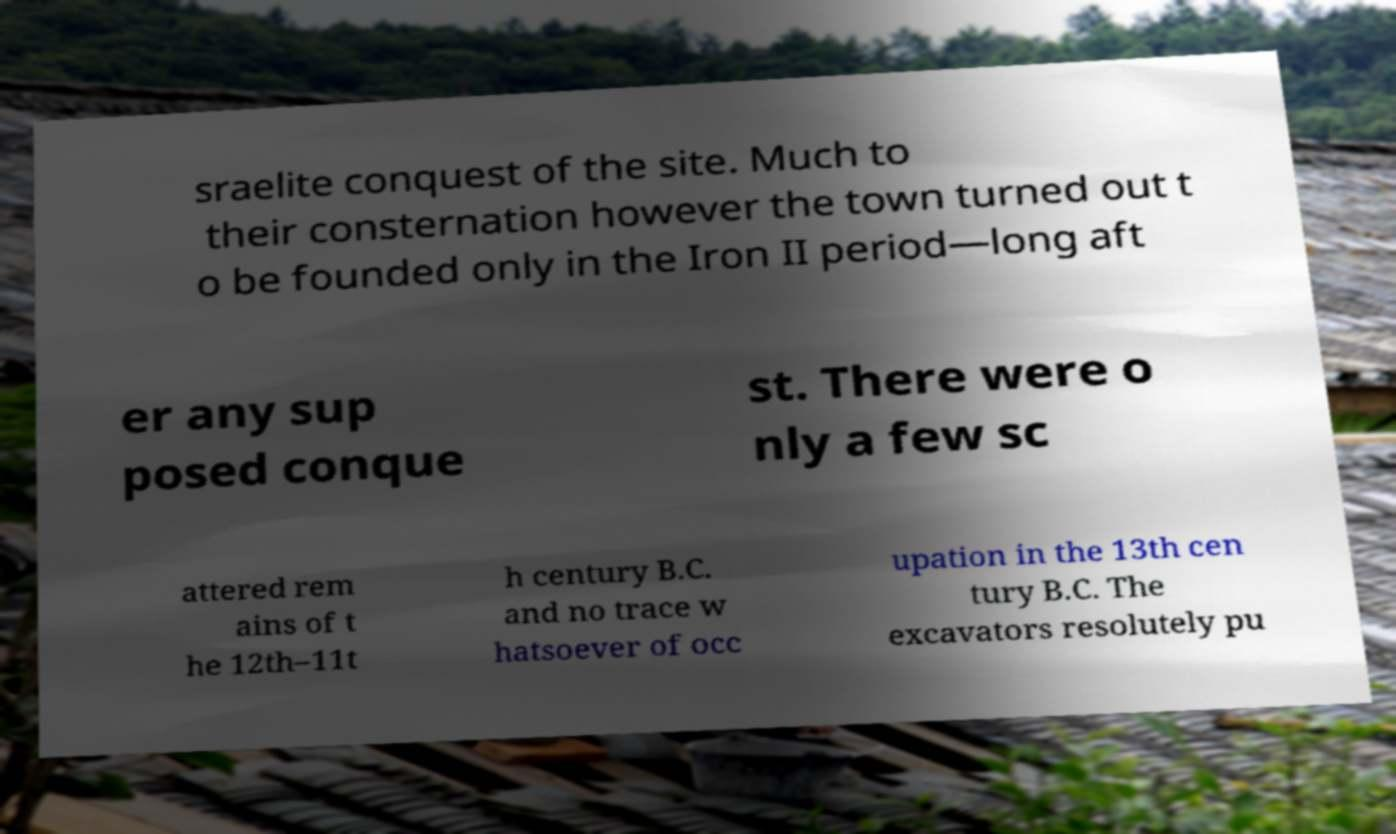Please identify and transcribe the text found in this image. sraelite conquest of the site. Much to their consternation however the town turned out t o be founded only in the Iron II period—long aft er any sup posed conque st. There were o nly a few sc attered rem ains of t he 12th–11t h century B.C. and no trace w hatsoever of occ upation in the 13th cen tury B.C. The excavators resolutely pu 